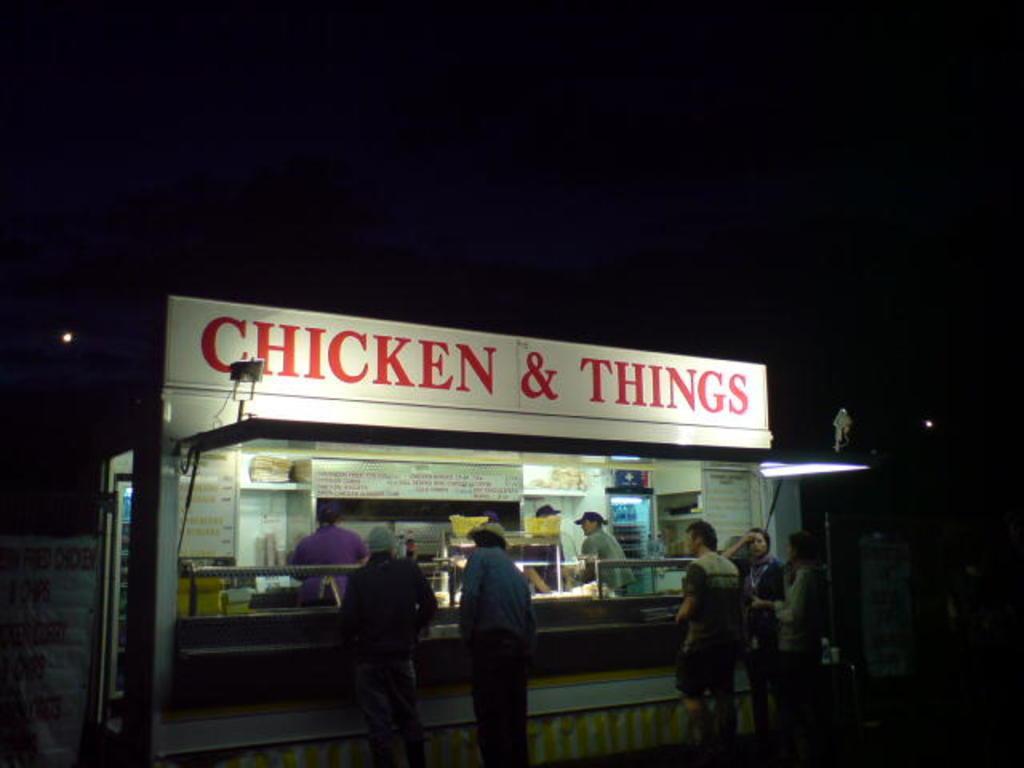Describe this image in one or two sentences. In this picture we can see the street food shop in the front. On the top there is a naming board. In the front there are some person standing at the food counter. Behind we can see the dark background. 